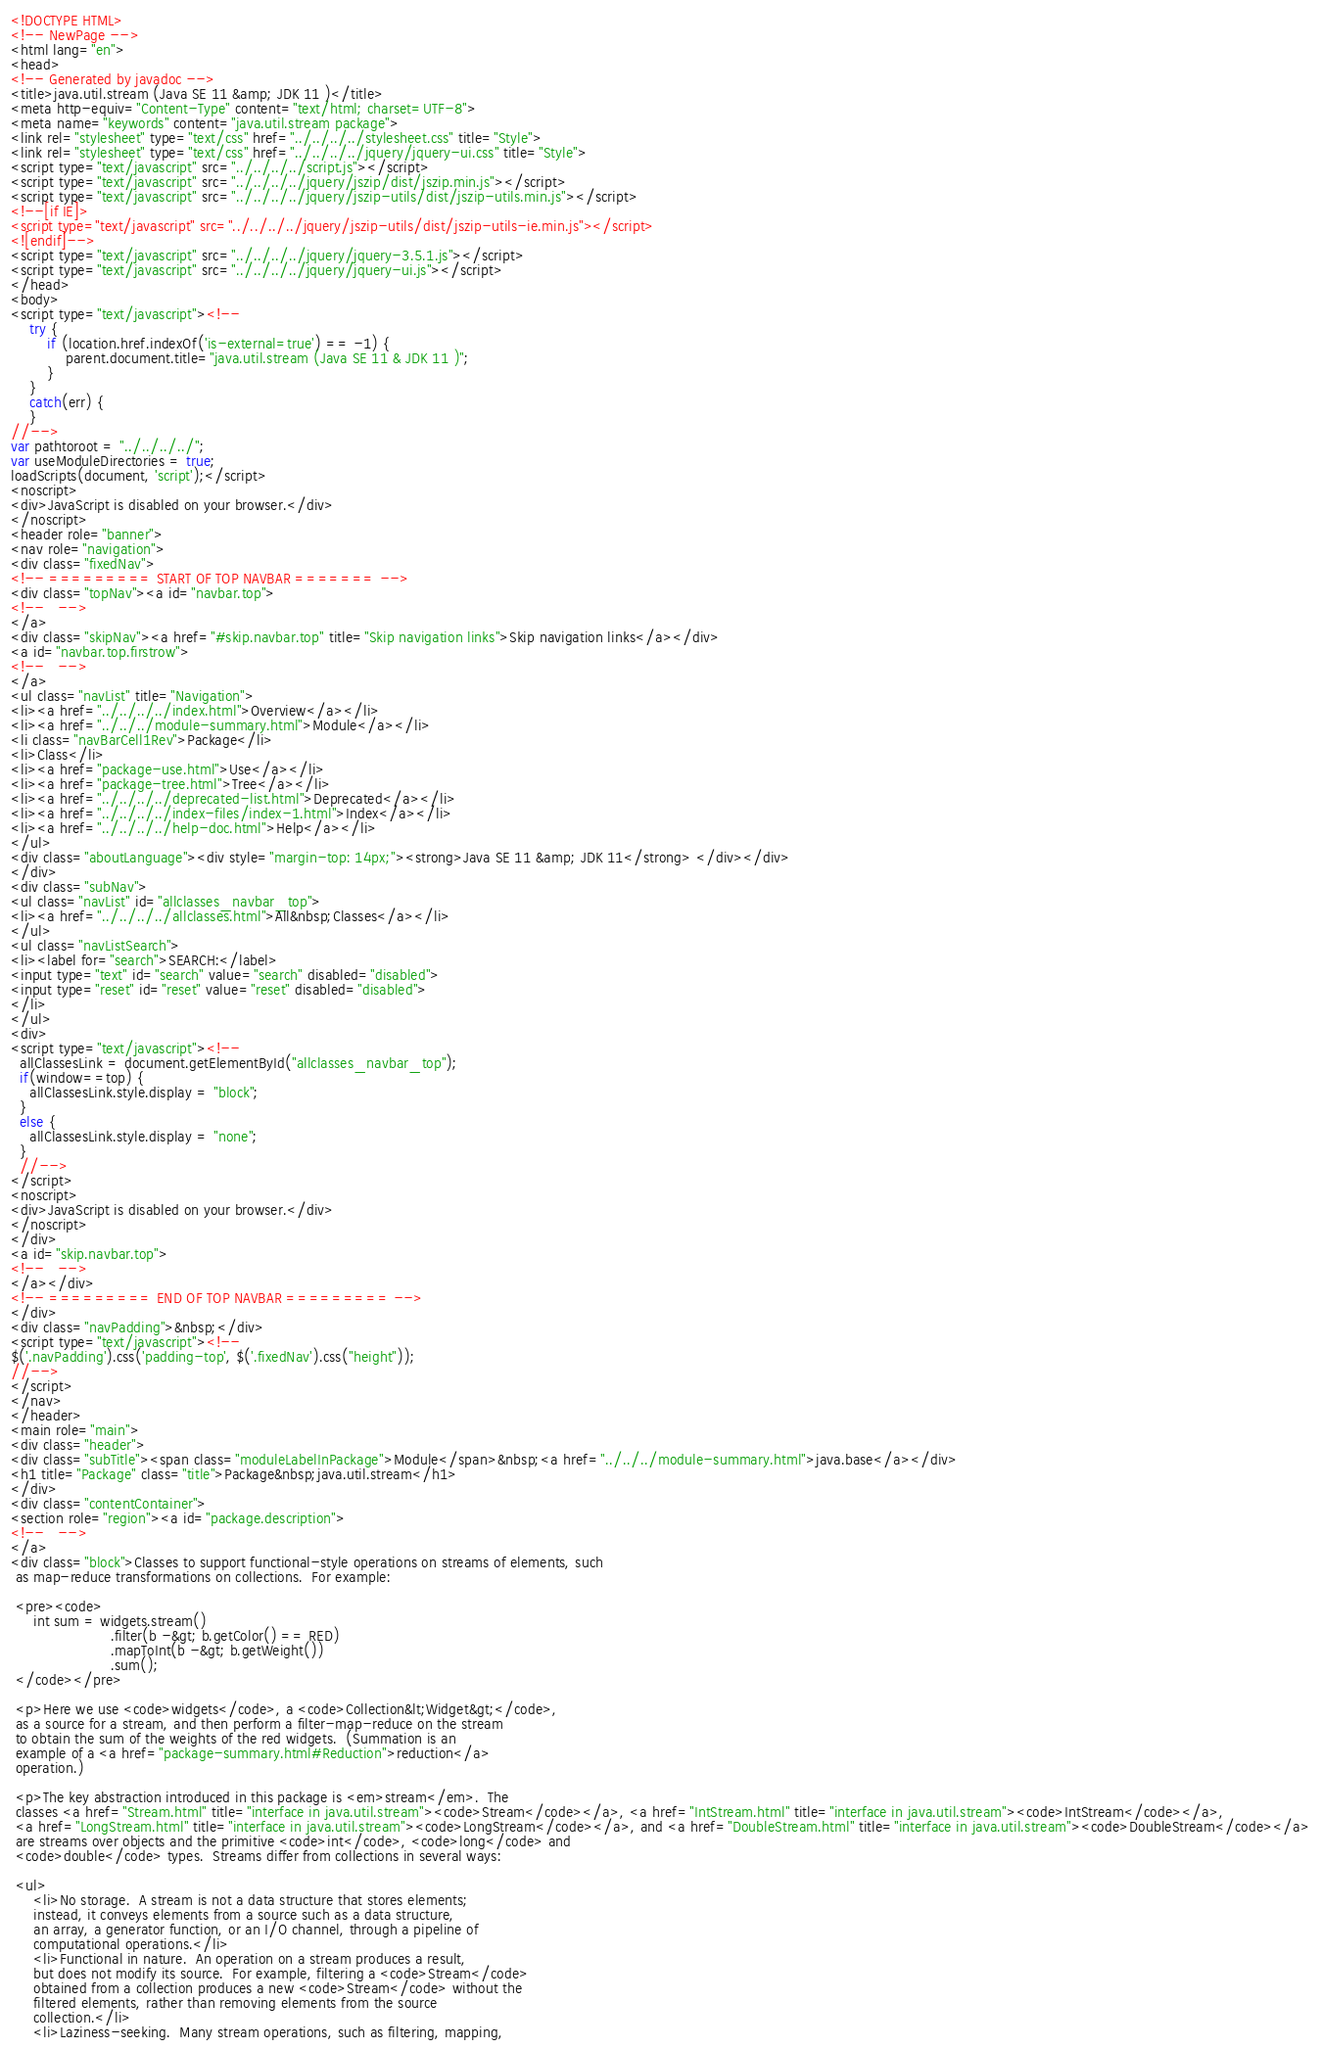<code> <loc_0><loc_0><loc_500><loc_500><_HTML_><!DOCTYPE HTML>
<!-- NewPage -->
<html lang="en">
<head>
<!-- Generated by javadoc -->
<title>java.util.stream (Java SE 11 &amp; JDK 11 )</title>
<meta http-equiv="Content-Type" content="text/html; charset=UTF-8">
<meta name="keywords" content="java.util.stream package">
<link rel="stylesheet" type="text/css" href="../../../../stylesheet.css" title="Style">
<link rel="stylesheet" type="text/css" href="../../../../jquery/jquery-ui.css" title="Style">
<script type="text/javascript" src="../../../../script.js"></script>
<script type="text/javascript" src="../../../../jquery/jszip/dist/jszip.min.js"></script>
<script type="text/javascript" src="../../../../jquery/jszip-utils/dist/jszip-utils.min.js"></script>
<!--[if IE]>
<script type="text/javascript" src="../../../../jquery/jszip-utils/dist/jszip-utils-ie.min.js"></script>
<![endif]-->
<script type="text/javascript" src="../../../../jquery/jquery-3.5.1.js"></script>
<script type="text/javascript" src="../../../../jquery/jquery-ui.js"></script>
</head>
<body>
<script type="text/javascript"><!--
    try {
        if (location.href.indexOf('is-external=true') == -1) {
            parent.document.title="java.util.stream (Java SE 11 & JDK 11 )";
        }
    }
    catch(err) {
    }
//-->
var pathtoroot = "../../../../";
var useModuleDirectories = true;
loadScripts(document, 'script');</script>
<noscript>
<div>JavaScript is disabled on your browser.</div>
</noscript>
<header role="banner">
<nav role="navigation">
<div class="fixedNav">
<!-- ========= START OF TOP NAVBAR ======= -->
<div class="topNav"><a id="navbar.top">
<!--   -->
</a>
<div class="skipNav"><a href="#skip.navbar.top" title="Skip navigation links">Skip navigation links</a></div>
<a id="navbar.top.firstrow">
<!--   -->
</a>
<ul class="navList" title="Navigation">
<li><a href="../../../../index.html">Overview</a></li>
<li><a href="../../../module-summary.html">Module</a></li>
<li class="navBarCell1Rev">Package</li>
<li>Class</li>
<li><a href="package-use.html">Use</a></li>
<li><a href="package-tree.html">Tree</a></li>
<li><a href="../../../../deprecated-list.html">Deprecated</a></li>
<li><a href="../../../../index-files/index-1.html">Index</a></li>
<li><a href="../../../../help-doc.html">Help</a></li>
</ul>
<div class="aboutLanguage"><div style="margin-top: 14px;"><strong>Java SE 11 &amp; JDK 11</strong> </div></div>
</div>
<div class="subNav">
<ul class="navList" id="allclasses_navbar_top">
<li><a href="../../../../allclasses.html">All&nbsp;Classes</a></li>
</ul>
<ul class="navListSearch">
<li><label for="search">SEARCH:</label>
<input type="text" id="search" value="search" disabled="disabled">
<input type="reset" id="reset" value="reset" disabled="disabled">
</li>
</ul>
<div>
<script type="text/javascript"><!--
  allClassesLink = document.getElementById("allclasses_navbar_top");
  if(window==top) {
    allClassesLink.style.display = "block";
  }
  else {
    allClassesLink.style.display = "none";
  }
  //-->
</script>
<noscript>
<div>JavaScript is disabled on your browser.</div>
</noscript>
</div>
<a id="skip.navbar.top">
<!--   -->
</a></div>
<!-- ========= END OF TOP NAVBAR ========= -->
</div>
<div class="navPadding">&nbsp;</div>
<script type="text/javascript"><!--
$('.navPadding').css('padding-top', $('.fixedNav').css("height"));
//-->
</script>
</nav>
</header>
<main role="main">
<div class="header">
<div class="subTitle"><span class="moduleLabelInPackage">Module</span>&nbsp;<a href="../../../module-summary.html">java.base</a></div>
<h1 title="Package" class="title">Package&nbsp;java.util.stream</h1>
</div>
<div class="contentContainer">
<section role="region"><a id="package.description">
<!--   -->
</a>
<div class="block">Classes to support functional-style operations on streams of elements, such
 as map-reduce transformations on collections.  For example:

 <pre><code>
     int sum = widgets.stream()
                      .filter(b -&gt; b.getColor() == RED)
                      .mapToInt(b -&gt; b.getWeight())
                      .sum();
 </code></pre>

 <p>Here we use <code>widgets</code>, a <code>Collection&lt;Widget&gt;</code>,
 as a source for a stream, and then perform a filter-map-reduce on the stream
 to obtain the sum of the weights of the red widgets.  (Summation is an
 example of a <a href="package-summary.html#Reduction">reduction</a>
 operation.)

 <p>The key abstraction introduced in this package is <em>stream</em>.  The
 classes <a href="Stream.html" title="interface in java.util.stream"><code>Stream</code></a>, <a href="IntStream.html" title="interface in java.util.stream"><code>IntStream</code></a>,
 <a href="LongStream.html" title="interface in java.util.stream"><code>LongStream</code></a>, and <a href="DoubleStream.html" title="interface in java.util.stream"><code>DoubleStream</code></a>
 are streams over objects and the primitive <code>int</code>, <code>long</code> and
 <code>double</code> types.  Streams differ from collections in several ways:

 <ul>
     <li>No storage.  A stream is not a data structure that stores elements;
     instead, it conveys elements from a source such as a data structure,
     an array, a generator function, or an I/O channel, through a pipeline of
     computational operations.</li>
     <li>Functional in nature.  An operation on a stream produces a result,
     but does not modify its source.  For example, filtering a <code>Stream</code>
     obtained from a collection produces a new <code>Stream</code> without the
     filtered elements, rather than removing elements from the source
     collection.</li>
     <li>Laziness-seeking.  Many stream operations, such as filtering, mapping,</code> 